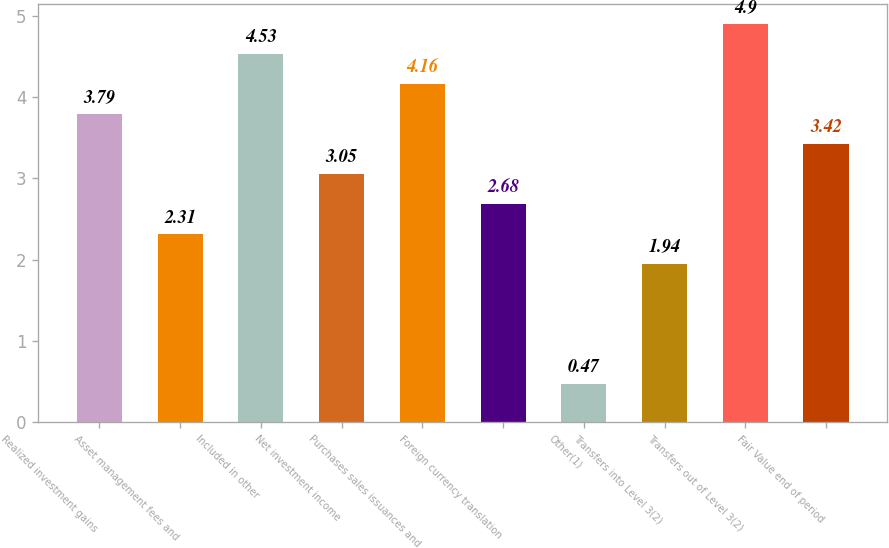<chart> <loc_0><loc_0><loc_500><loc_500><bar_chart><fcel>Realized investment gains<fcel>Asset management fees and<fcel>Included in other<fcel>Net investment income<fcel>Purchases sales issuances and<fcel>Foreign currency translation<fcel>Other(1)<fcel>Transfers into Level 3(2)<fcel>Transfers out of Level 3(2)<fcel>Fair Value end of period<nl><fcel>3.79<fcel>2.31<fcel>4.53<fcel>3.05<fcel>4.16<fcel>2.68<fcel>0.47<fcel>1.94<fcel>4.9<fcel>3.42<nl></chart> 